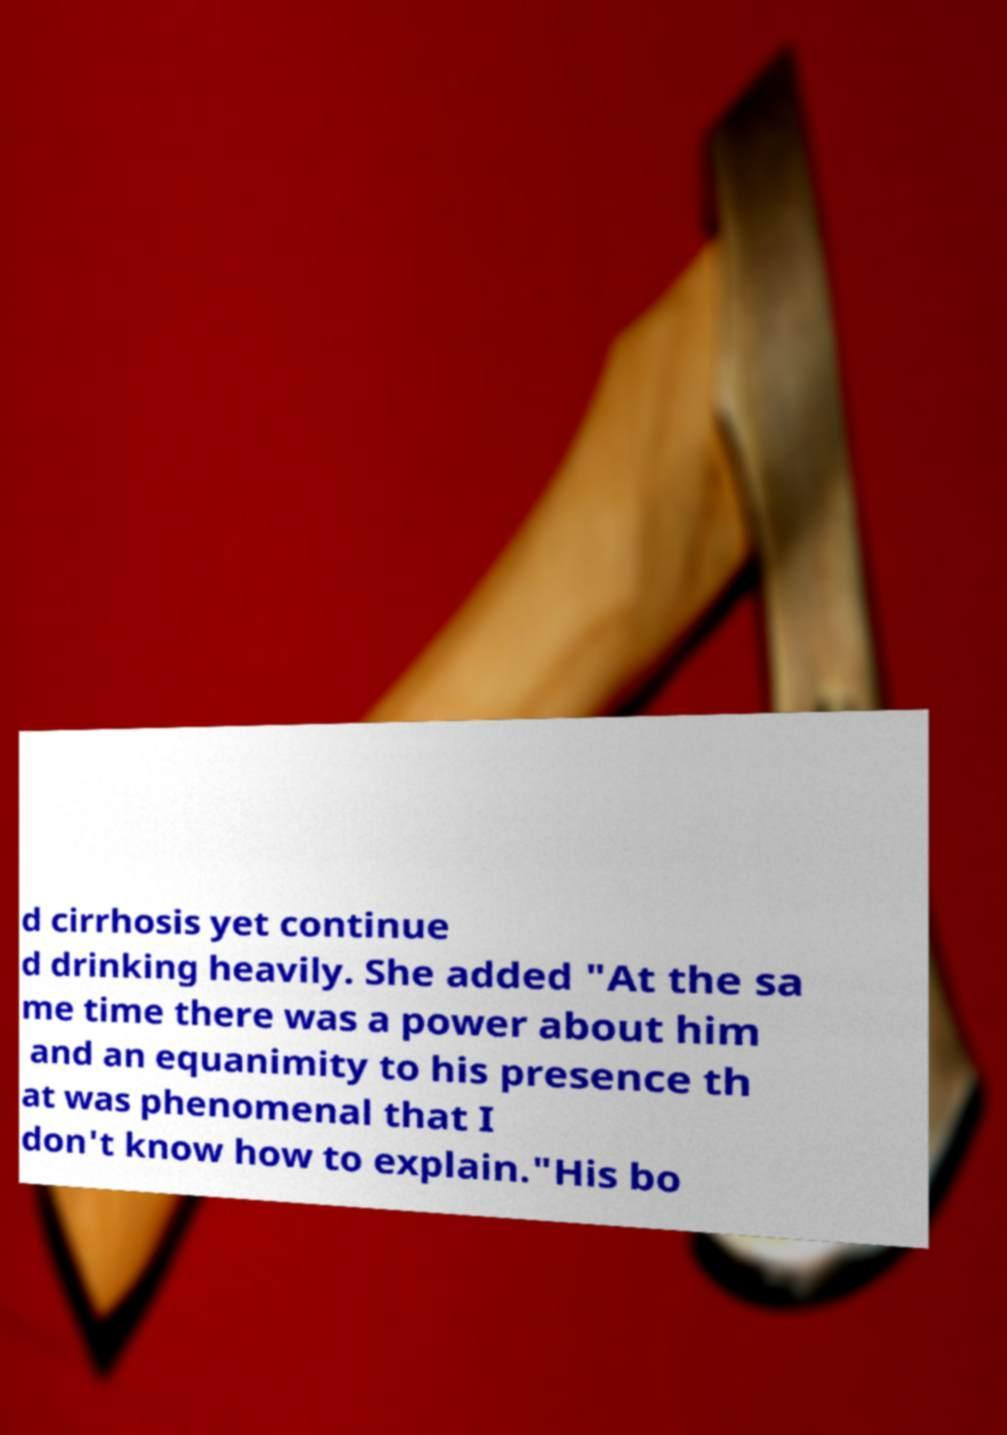For documentation purposes, I need the text within this image transcribed. Could you provide that? d cirrhosis yet continue d drinking heavily. She added "At the sa me time there was a power about him and an equanimity to his presence th at was phenomenal that I don't know how to explain."His bo 